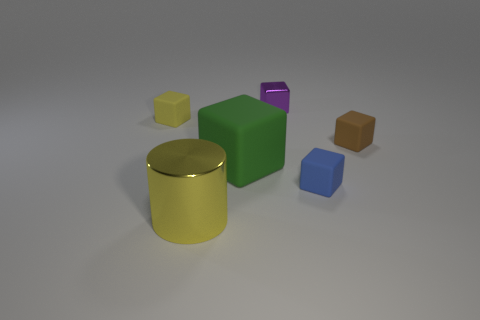What material is the small thing that is the same color as the big metal cylinder?
Ensure brevity in your answer.  Rubber. There is a object that is both in front of the big matte object and to the left of the tiny blue object; what shape is it?
Keep it short and to the point. Cylinder. What color is the other small metal thing that is the same shape as the small brown object?
Ensure brevity in your answer.  Purple. What number of objects are either cubes behind the tiny blue matte block or rubber cubes in front of the green matte thing?
Make the answer very short. 5. There is a tiny blue object; what shape is it?
Offer a very short reply. Cube. What is the shape of the other thing that is the same color as the big metallic object?
Ensure brevity in your answer.  Cube. What number of small blue things have the same material as the large block?
Your response must be concise. 1. The tiny metallic cube is what color?
Give a very brief answer. Purple. What color is the thing that is the same size as the cylinder?
Provide a short and direct response. Green. Are there any shiny cylinders that have the same color as the large metallic object?
Offer a terse response. No. 